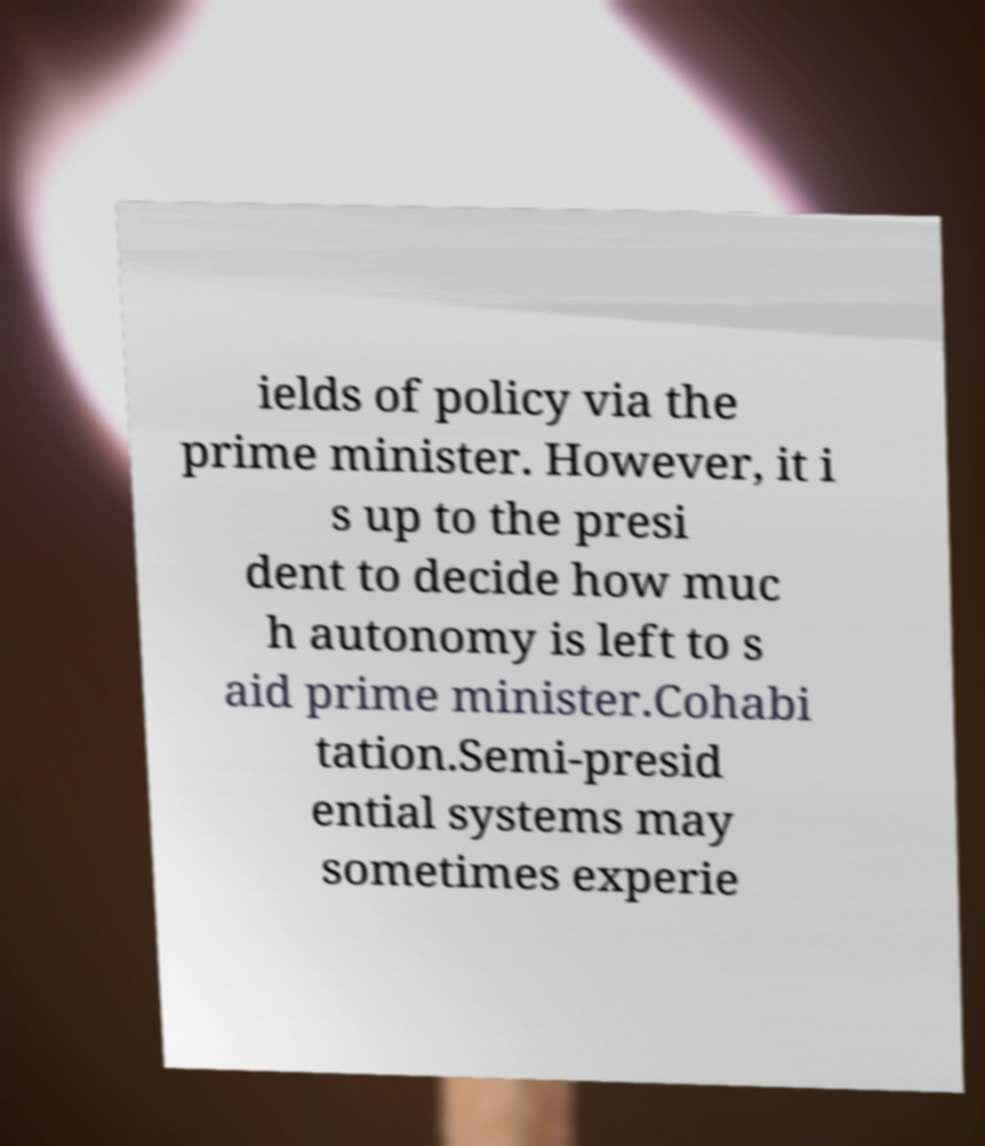Please read and relay the text visible in this image. What does it say? ields of policy via the prime minister. However, it i s up to the presi dent to decide how muc h autonomy is left to s aid prime minister.Cohabi tation.Semi-presid ential systems may sometimes experie 